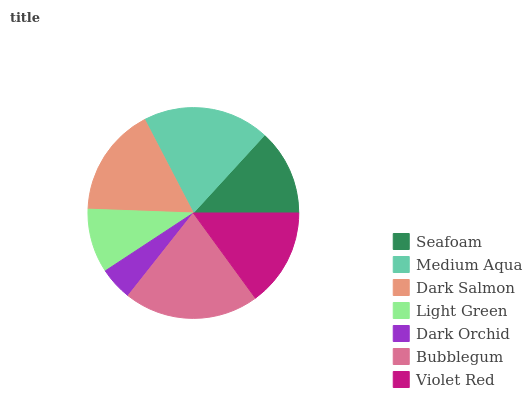Is Dark Orchid the minimum?
Answer yes or no. Yes. Is Bubblegum the maximum?
Answer yes or no. Yes. Is Medium Aqua the minimum?
Answer yes or no. No. Is Medium Aqua the maximum?
Answer yes or no. No. Is Medium Aqua greater than Seafoam?
Answer yes or no. Yes. Is Seafoam less than Medium Aqua?
Answer yes or no. Yes. Is Seafoam greater than Medium Aqua?
Answer yes or no. No. Is Medium Aqua less than Seafoam?
Answer yes or no. No. Is Violet Red the high median?
Answer yes or no. Yes. Is Violet Red the low median?
Answer yes or no. Yes. Is Medium Aqua the high median?
Answer yes or no. No. Is Bubblegum the low median?
Answer yes or no. No. 